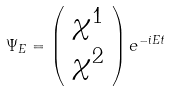Convert formula to latex. <formula><loc_0><loc_0><loc_500><loc_500>\Psi _ { E } = \left ( \begin{array} { c } { { \chi ^ { 1 } } } \\ { { \chi ^ { 2 } } } \end{array} \right ) e ^ { - i E t }</formula> 